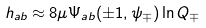Convert formula to latex. <formula><loc_0><loc_0><loc_500><loc_500>h _ { a b } \approx 8 \mu \Psi _ { a b } ( \pm 1 , \psi _ { \mp } ) \ln Q _ { \mp }</formula> 